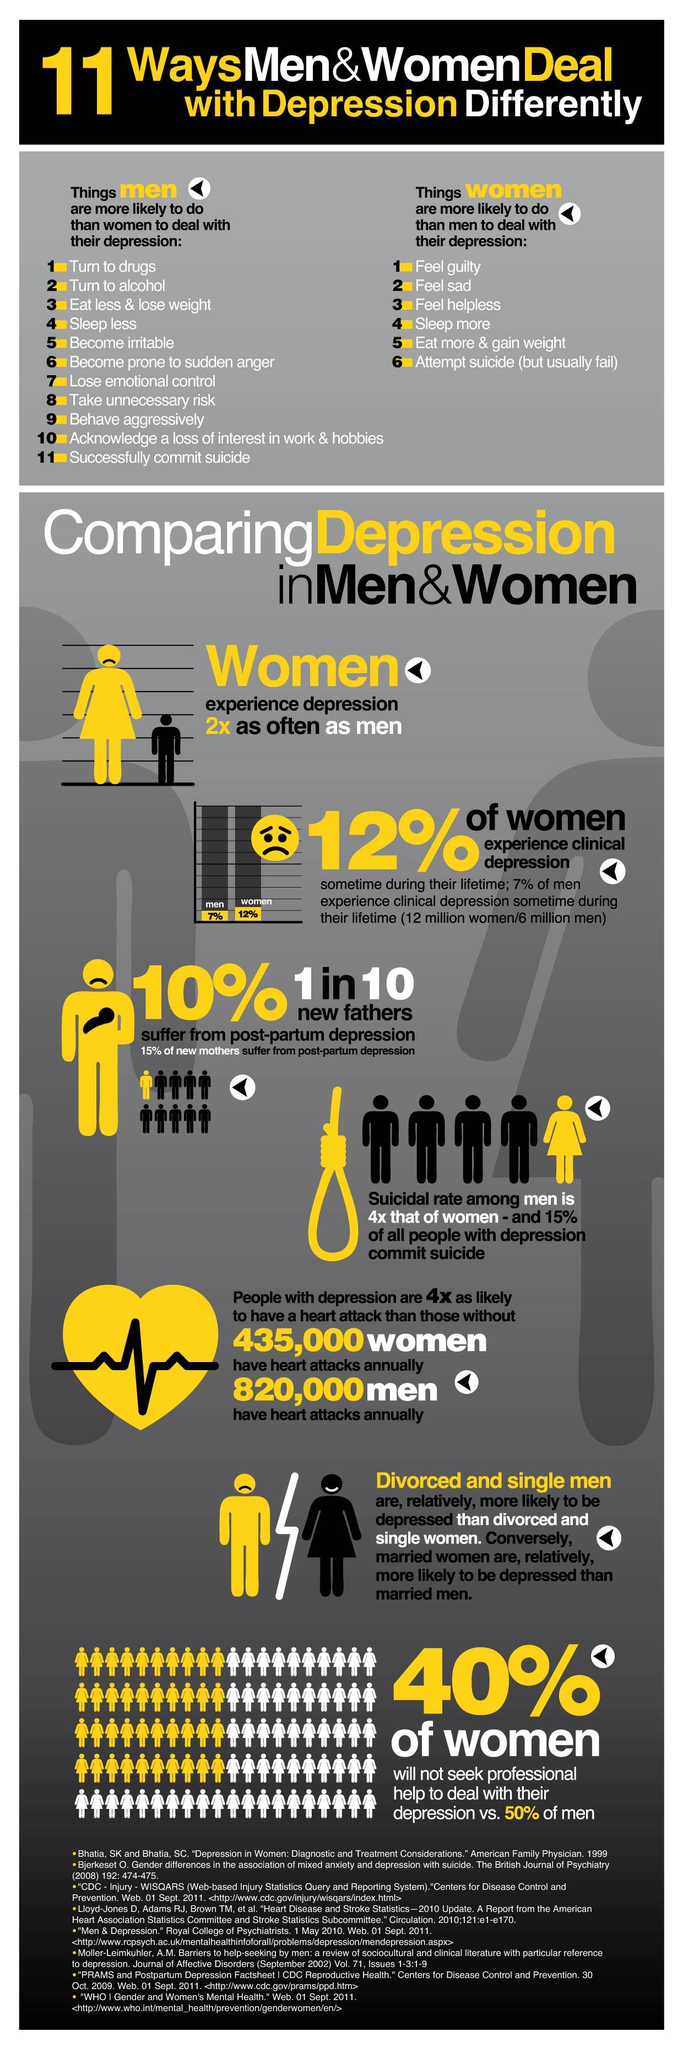Point out several critical features in this image. According to the given information, 88% of women have not experienced clinical depression. According to a recent survey, 93% of men have not experienced clinical depression. Eighty-five percent of new mothers are not suffering from post-partum depression. According to a recent survey, 60% of women seek professional help to manage their depression symptoms. Out of 10 new fathers, approximately 9 suffer from post-partum depression. 